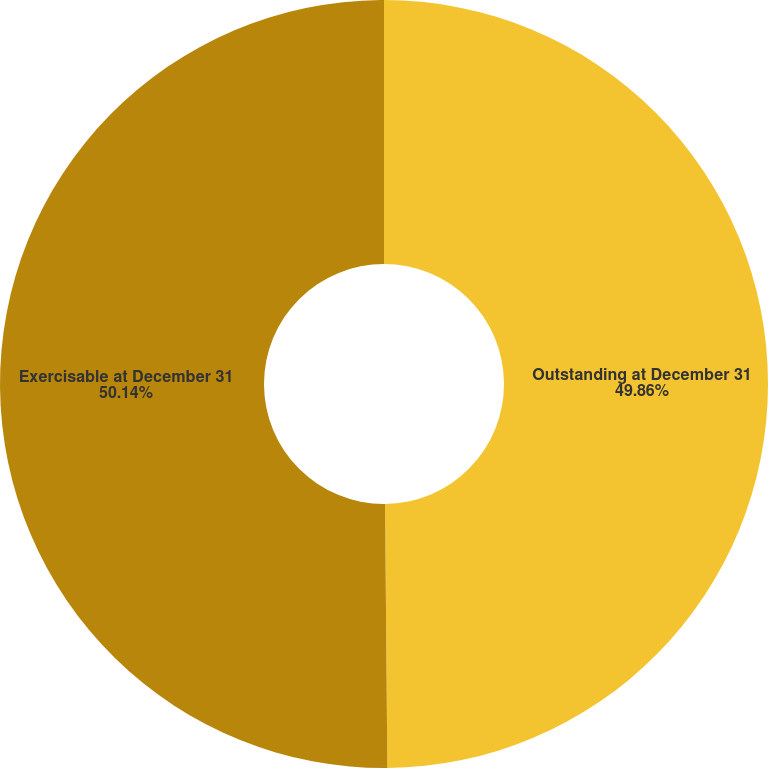Convert chart to OTSL. <chart><loc_0><loc_0><loc_500><loc_500><pie_chart><fcel>Outstanding at December 31<fcel>Exercisable at December 31<nl><fcel>49.86%<fcel>50.14%<nl></chart> 